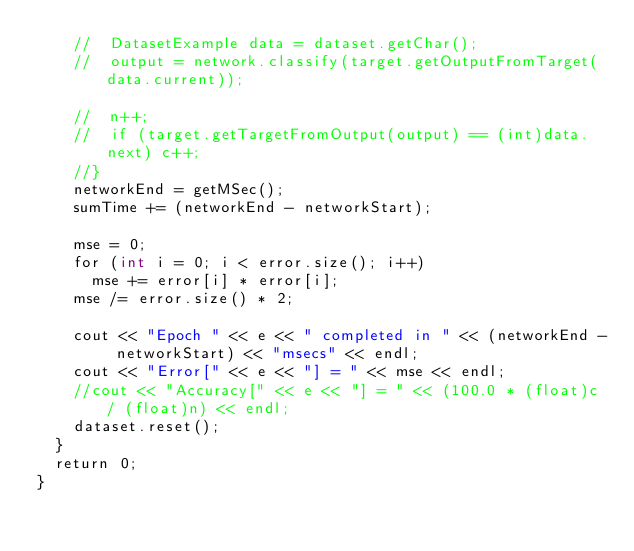Convert code to text. <code><loc_0><loc_0><loc_500><loc_500><_Cuda_>		//	DatasetExample data = dataset.getChar();
		//	output = network.classify(target.getOutputFromTarget(data.current));

		//	n++;
		//	if (target.getTargetFromOutput(output) == (int)data.next) c++;
		//}
		networkEnd = getMSec();
		sumTime += (networkEnd - networkStart);

		mse = 0;
		for (int i = 0; i < error.size(); i++)
			mse += error[i] * error[i];
		mse /= error.size() * 2;

		cout << "Epoch " << e << " completed in " << (networkEnd - networkStart) << "msecs" << endl;
		cout << "Error[" << e << "] = " << mse << endl;
		//cout << "Accuracy[" << e << "] = " << (100.0 * (float)c / (float)n) << endl;
		dataset.reset();
	}
	return 0;
}
</code> 